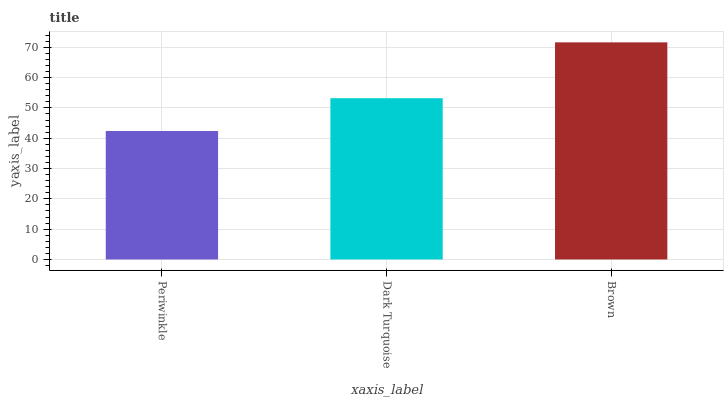Is Dark Turquoise the minimum?
Answer yes or no. No. Is Dark Turquoise the maximum?
Answer yes or no. No. Is Dark Turquoise greater than Periwinkle?
Answer yes or no. Yes. Is Periwinkle less than Dark Turquoise?
Answer yes or no. Yes. Is Periwinkle greater than Dark Turquoise?
Answer yes or no. No. Is Dark Turquoise less than Periwinkle?
Answer yes or no. No. Is Dark Turquoise the high median?
Answer yes or no. Yes. Is Dark Turquoise the low median?
Answer yes or no. Yes. Is Brown the high median?
Answer yes or no. No. Is Brown the low median?
Answer yes or no. No. 